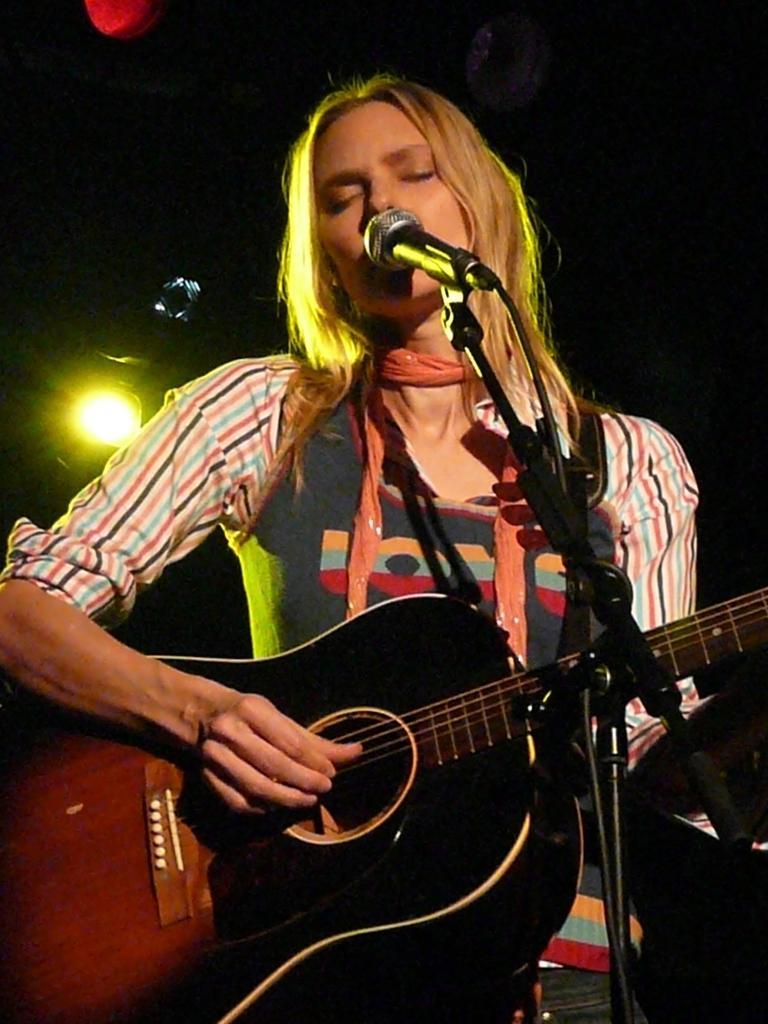How would you summarize this image in a sentence or two? In the middle of the image a woman is standing and playing guitar and singing on the microphone. Behind her there are few lights. She wears a scarf. 